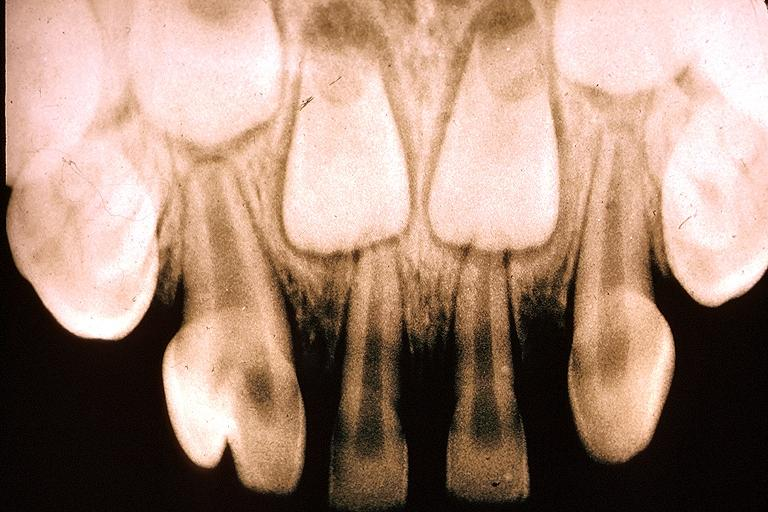what is present?
Answer the question using a single word or phrase. Oral 